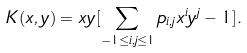Convert formula to latex. <formula><loc_0><loc_0><loc_500><loc_500>K ( x , y ) = x y [ \sum _ { - 1 \leq i , j \leq 1 } p _ { i , j } x ^ { i } y ^ { j } - 1 ] .</formula> 